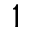<formula> <loc_0><loc_0><loc_500><loc_500>1</formula> 